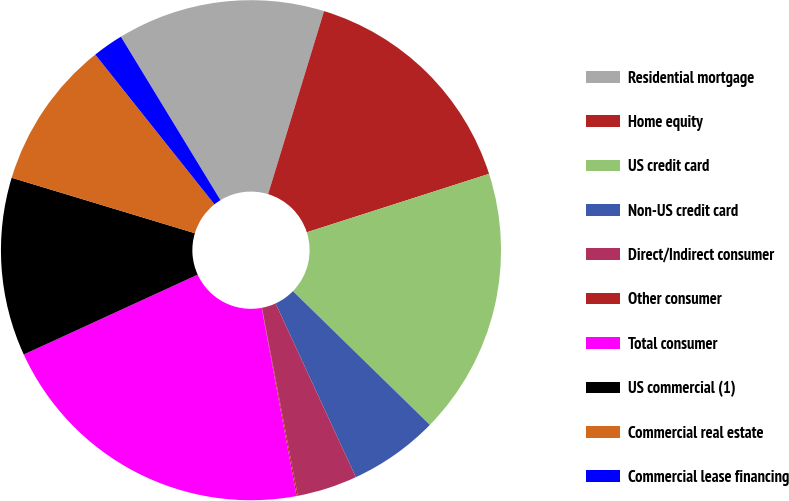Convert chart to OTSL. <chart><loc_0><loc_0><loc_500><loc_500><pie_chart><fcel>Residential mortgage<fcel>Home equity<fcel>US credit card<fcel>Non-US credit card<fcel>Direct/Indirect consumer<fcel>Other consumer<fcel>Total consumer<fcel>US commercial (1)<fcel>Commercial real estate<fcel>Commercial lease financing<nl><fcel>13.43%<fcel>15.34%<fcel>17.25%<fcel>5.8%<fcel>3.89%<fcel>0.08%<fcel>21.07%<fcel>11.53%<fcel>9.62%<fcel>1.99%<nl></chart> 